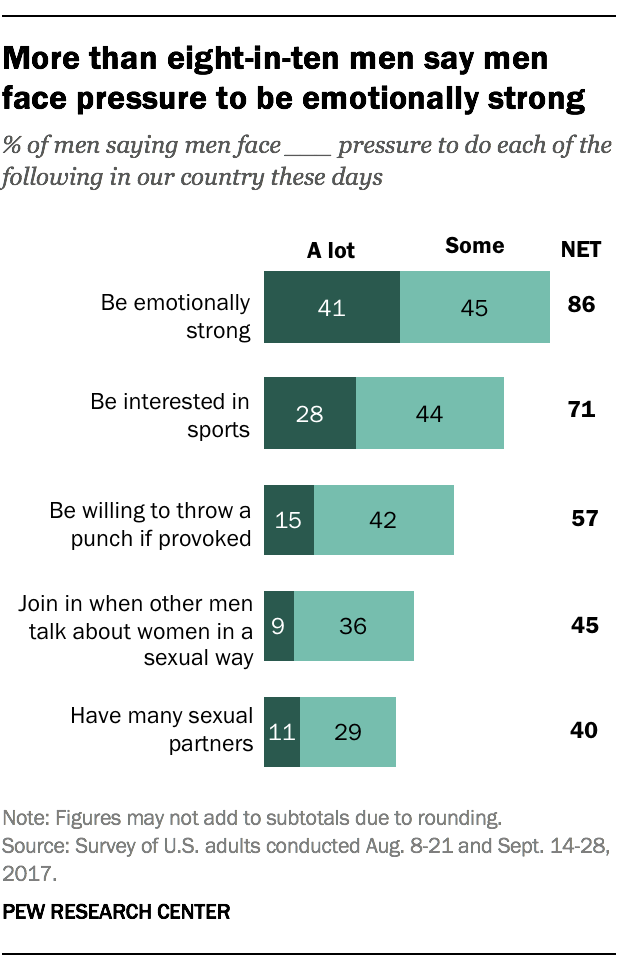Outline some significant characteristics in this image. According to a recent survey, 44% of men have some interest in sports. The average of the "A lot" bars is not greater than the smallest "Some" bar. 